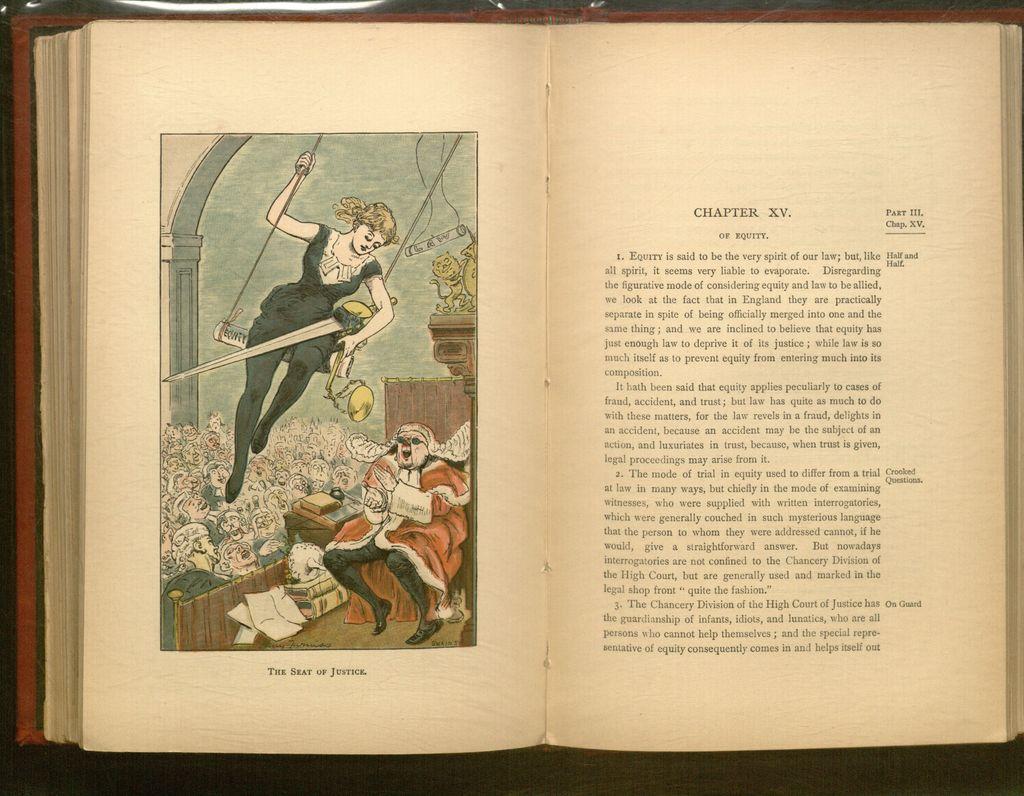What is the caption under the drawing?
Offer a terse response. The seat of justice. 